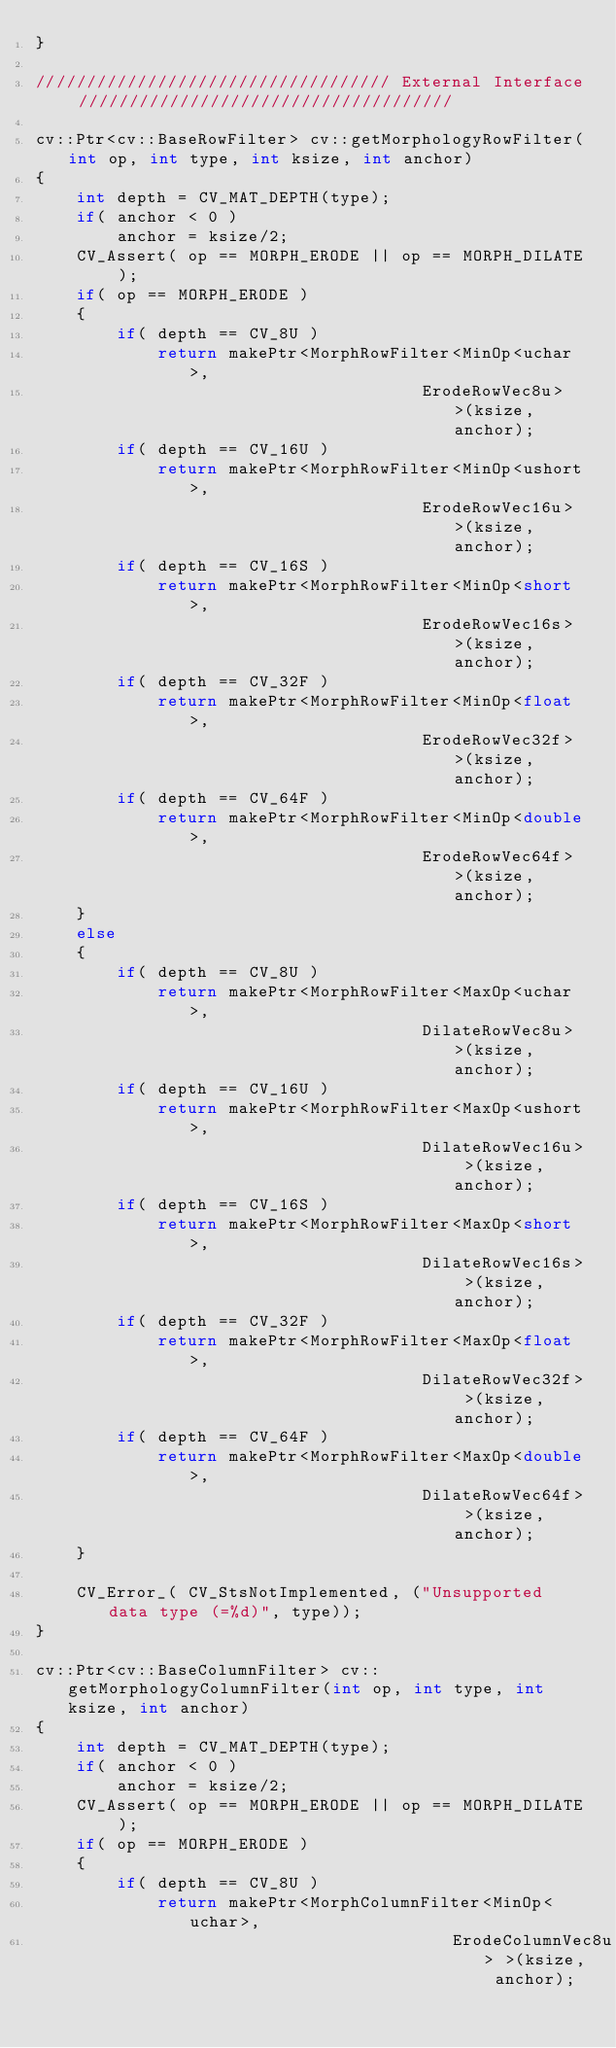<code> <loc_0><loc_0><loc_500><loc_500><_C++_>}

/////////////////////////////////// External Interface /////////////////////////////////////

cv::Ptr<cv::BaseRowFilter> cv::getMorphologyRowFilter(int op, int type, int ksize, int anchor)
{
    int depth = CV_MAT_DEPTH(type);
    if( anchor < 0 )
        anchor = ksize/2;
    CV_Assert( op == MORPH_ERODE || op == MORPH_DILATE );
    if( op == MORPH_ERODE )
    {
        if( depth == CV_8U )
            return makePtr<MorphRowFilter<MinOp<uchar>,
                                      ErodeRowVec8u> >(ksize, anchor);
        if( depth == CV_16U )
            return makePtr<MorphRowFilter<MinOp<ushort>,
                                      ErodeRowVec16u> >(ksize, anchor);
        if( depth == CV_16S )
            return makePtr<MorphRowFilter<MinOp<short>,
                                      ErodeRowVec16s> >(ksize, anchor);
        if( depth == CV_32F )
            return makePtr<MorphRowFilter<MinOp<float>,
                                      ErodeRowVec32f> >(ksize, anchor);
        if( depth == CV_64F )
            return makePtr<MorphRowFilter<MinOp<double>,
                                      ErodeRowVec64f> >(ksize, anchor);
    }
    else
    {
        if( depth == CV_8U )
            return makePtr<MorphRowFilter<MaxOp<uchar>,
                                      DilateRowVec8u> >(ksize, anchor);
        if( depth == CV_16U )
            return makePtr<MorphRowFilter<MaxOp<ushort>,
                                      DilateRowVec16u> >(ksize, anchor);
        if( depth == CV_16S )
            return makePtr<MorphRowFilter<MaxOp<short>,
                                      DilateRowVec16s> >(ksize, anchor);
        if( depth == CV_32F )
            return makePtr<MorphRowFilter<MaxOp<float>,
                                      DilateRowVec32f> >(ksize, anchor);
        if( depth == CV_64F )
            return makePtr<MorphRowFilter<MaxOp<double>,
                                      DilateRowVec64f> >(ksize, anchor);
    }

    CV_Error_( CV_StsNotImplemented, ("Unsupported data type (=%d)", type));
}

cv::Ptr<cv::BaseColumnFilter> cv::getMorphologyColumnFilter(int op, int type, int ksize, int anchor)
{
    int depth = CV_MAT_DEPTH(type);
    if( anchor < 0 )
        anchor = ksize/2;
    CV_Assert( op == MORPH_ERODE || op == MORPH_DILATE );
    if( op == MORPH_ERODE )
    {
        if( depth == CV_8U )
            return makePtr<MorphColumnFilter<MinOp<uchar>,
                                         ErodeColumnVec8u> >(ksize, anchor);</code> 